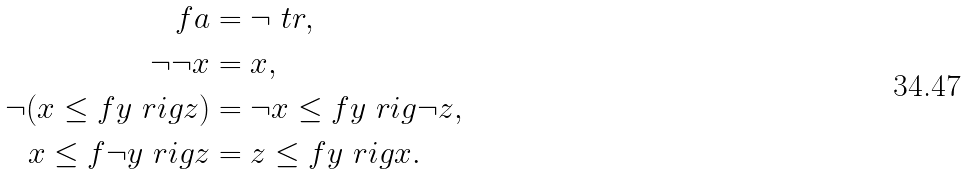Convert formula to latex. <formula><loc_0><loc_0><loc_500><loc_500>\ f a & = \neg \ t r , \\ \neg \neg x & = x , \\ \neg ( x \leq f y \ r i g z ) & = \neg x \leq f y \ r i g \neg z , \\ x \leq f \neg y \ r i g z & = z \leq f y \ r i g x .</formula> 